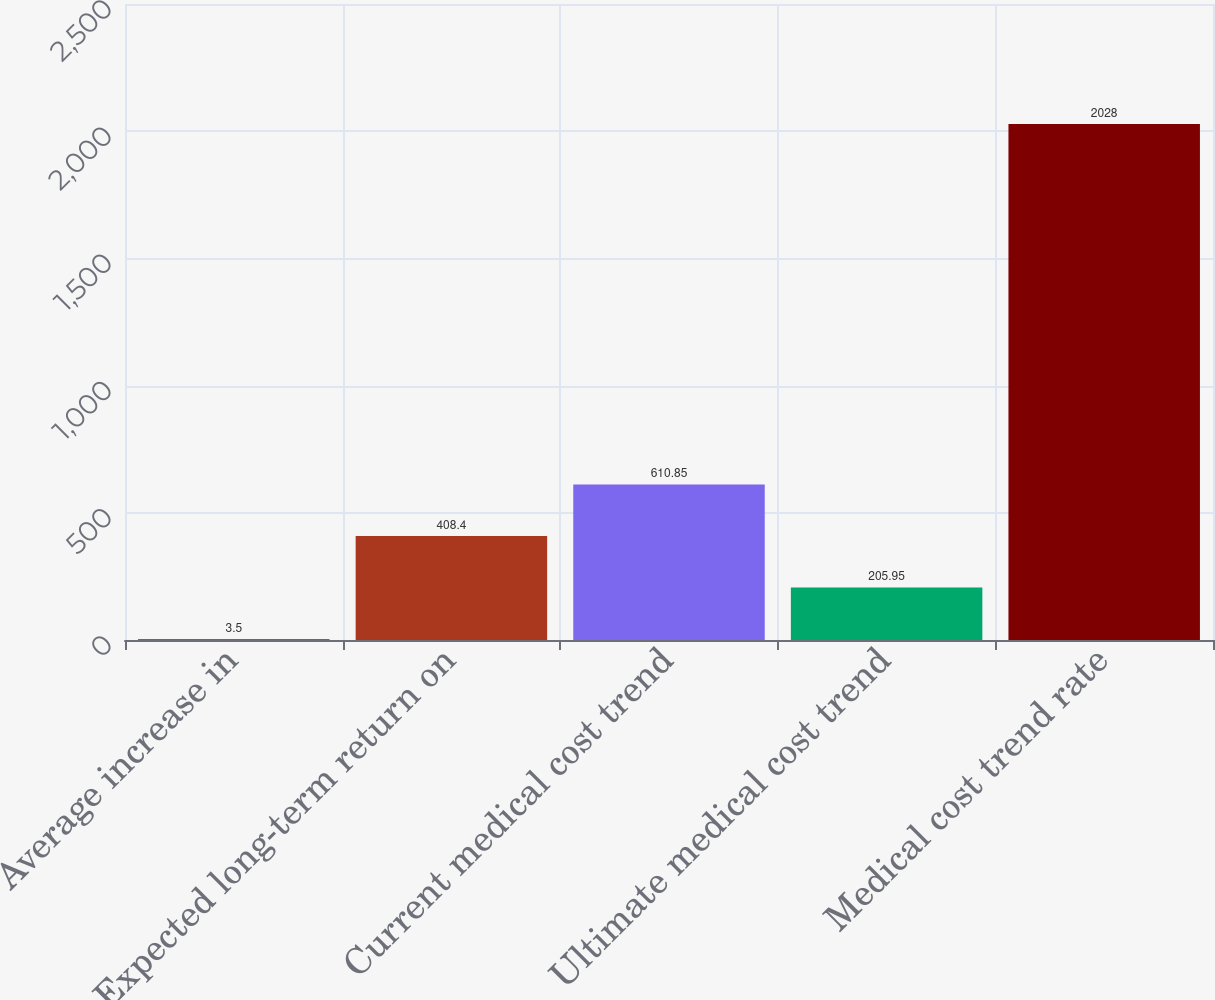<chart> <loc_0><loc_0><loc_500><loc_500><bar_chart><fcel>Average increase in<fcel>Expected long-term return on<fcel>Current medical cost trend<fcel>Ultimate medical cost trend<fcel>Medical cost trend rate<nl><fcel>3.5<fcel>408.4<fcel>610.85<fcel>205.95<fcel>2028<nl></chart> 